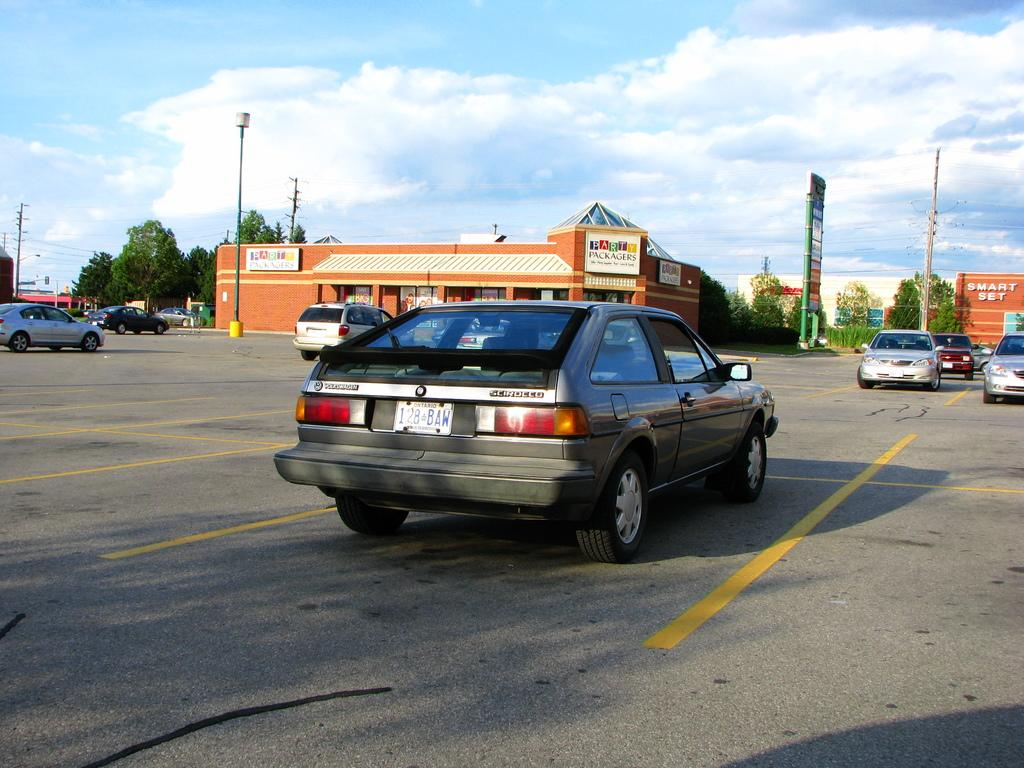What is the main subject of the image? The main subject of the image is cars on a road. What can be seen in the background of the image? In the background of the image, there are poles, buildings, trees, and the sky. How many elements can be identified in the background? There are four elements in the background: poles, buildings, trees, and the sky. What type of milk is being spilled on the patch of grass in the image? There is no milk or patch of grass present in the image. How many crackers are visible on the road in the image? There are no crackers visible on the road in the image. 